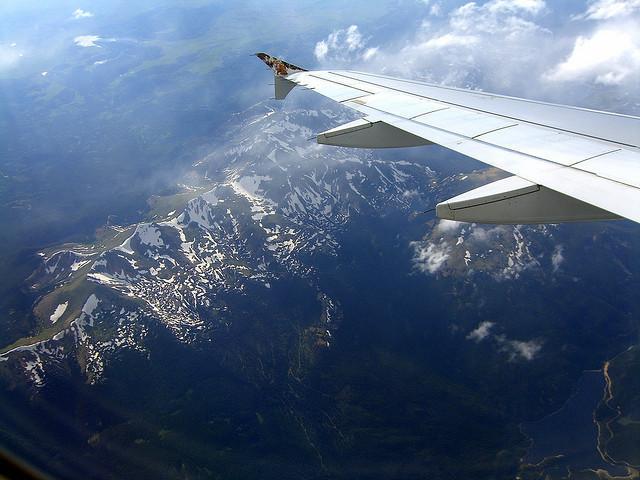How many people in the shot?
Give a very brief answer. 0. 